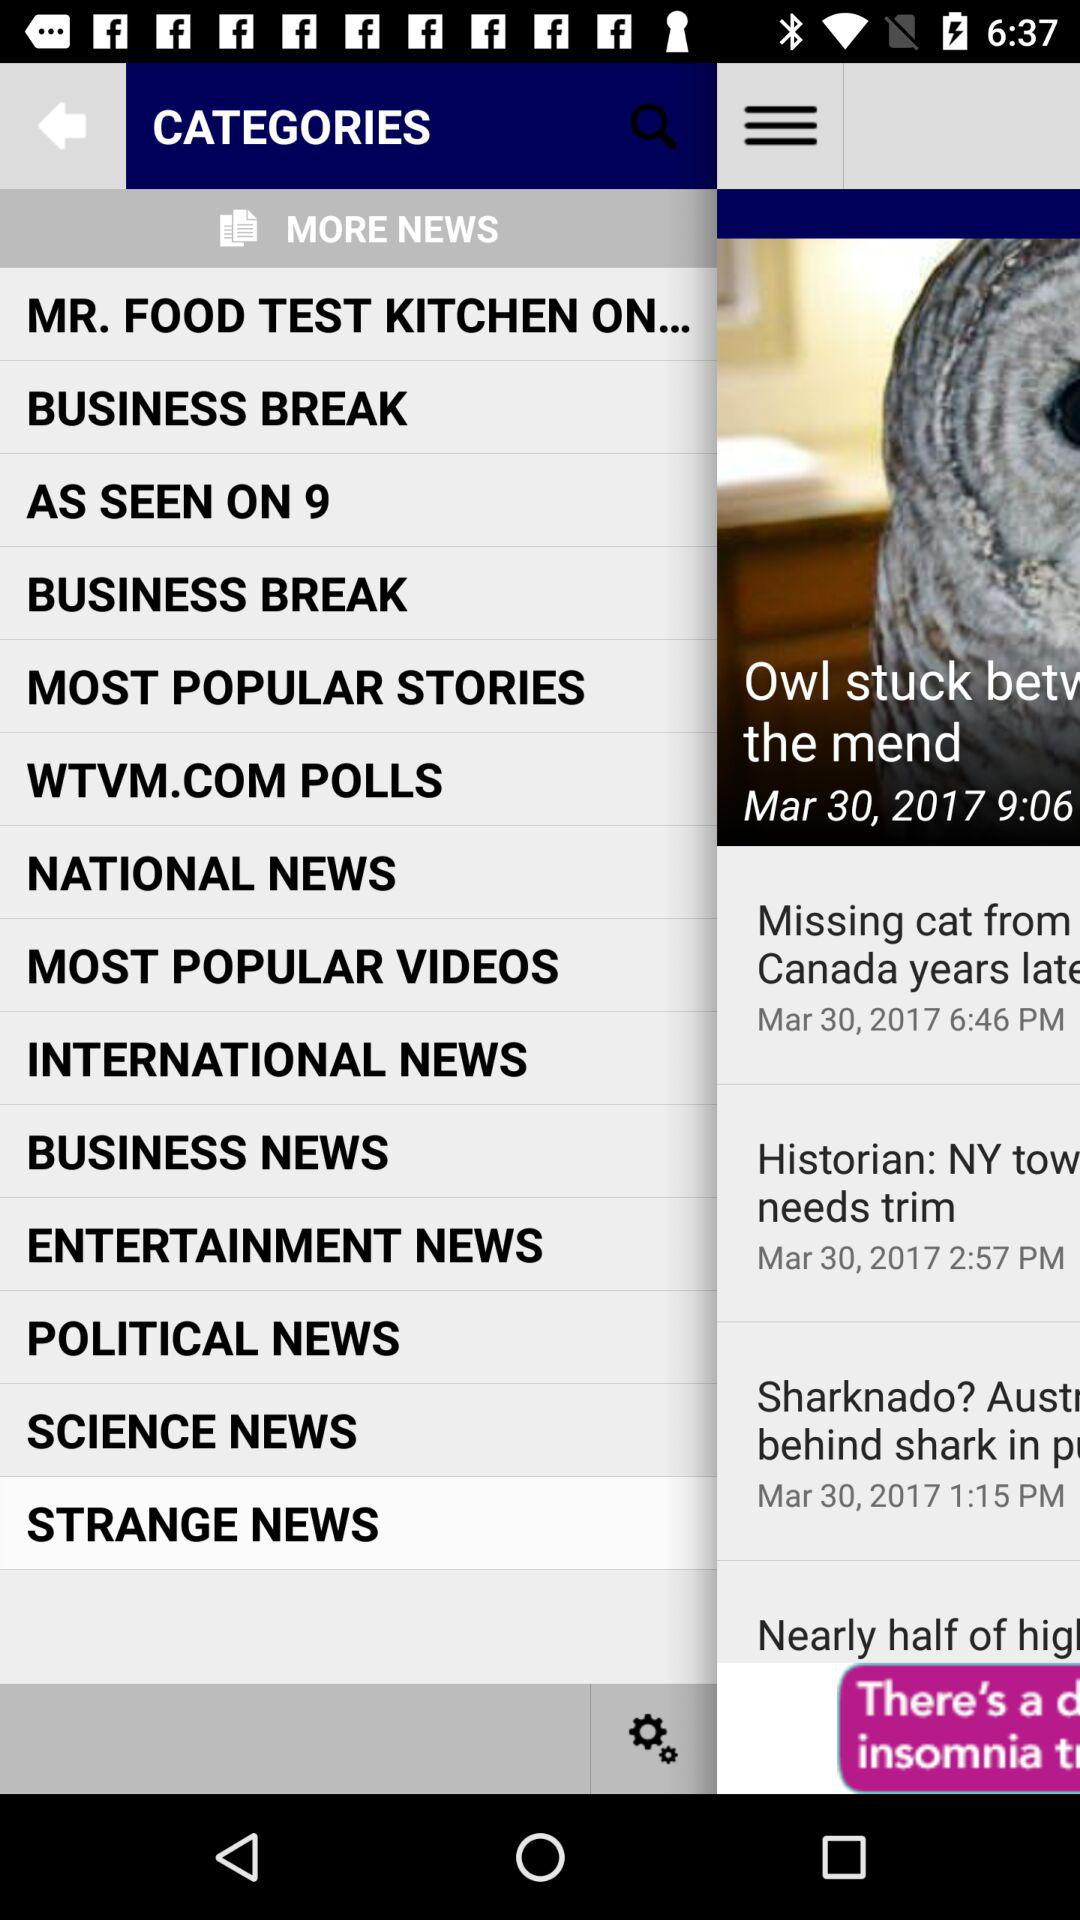What is the date? The date is March 30, 2017. 